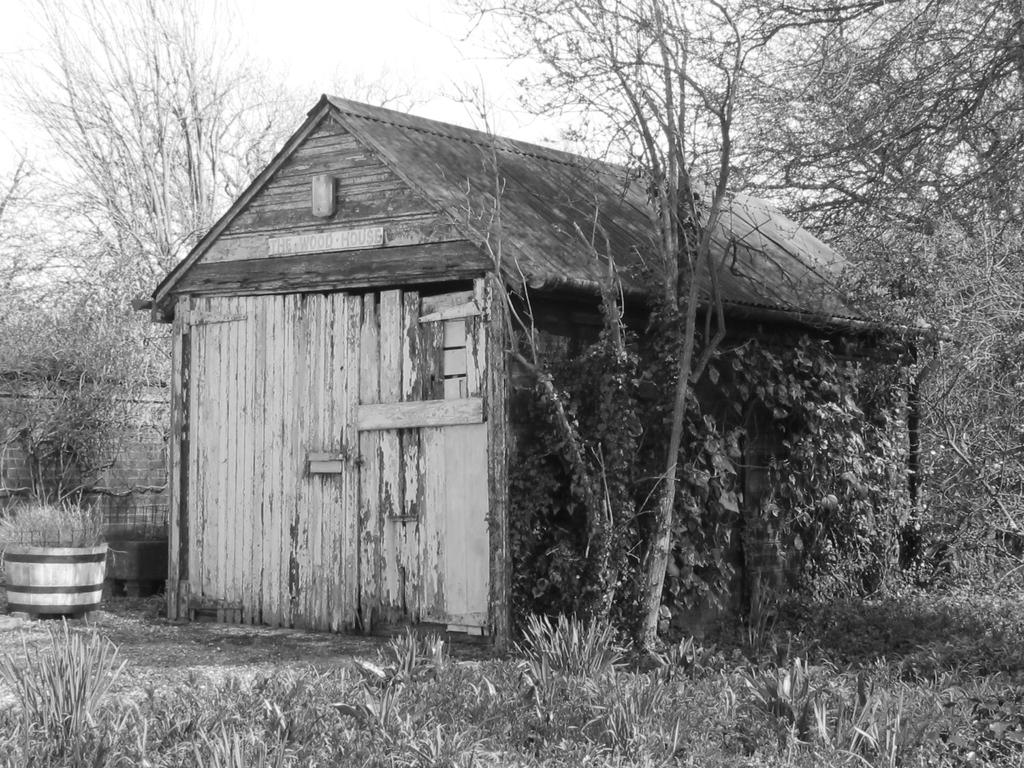What is the color scheme of the image? The image is black and white. What type of natural elements can be seen in the image? There are trees in the image. What type of structure is present in the image? There is a house in the image. What object can be seen in addition to the trees and house? There is a pot in the image. Is there a collar visible on any of the trees in the image? No, there is no collar present on any of the trees in the image. 